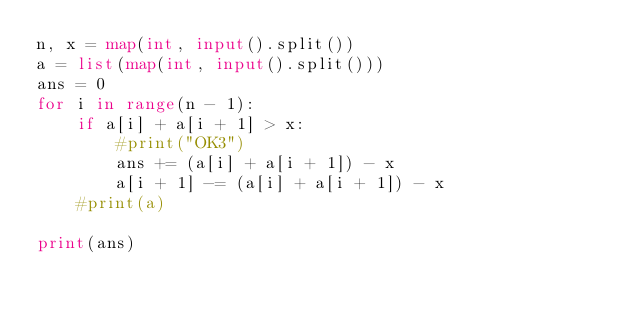Convert code to text. <code><loc_0><loc_0><loc_500><loc_500><_Python_>n, x = map(int, input().split())
a = list(map(int, input().split()))
ans = 0
for i in range(n - 1):
    if a[i] + a[i + 1] > x:
        #print("OK3")
        ans += (a[i] + a[i + 1]) - x
        a[i + 1] -= (a[i] + a[i + 1]) - x
    #print(a)

print(ans)</code> 